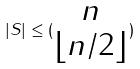Convert formula to latex. <formula><loc_0><loc_0><loc_500><loc_500>| S | \leq ( \begin{matrix} n \\ \lfloor n / 2 \rfloor \end{matrix} )</formula> 